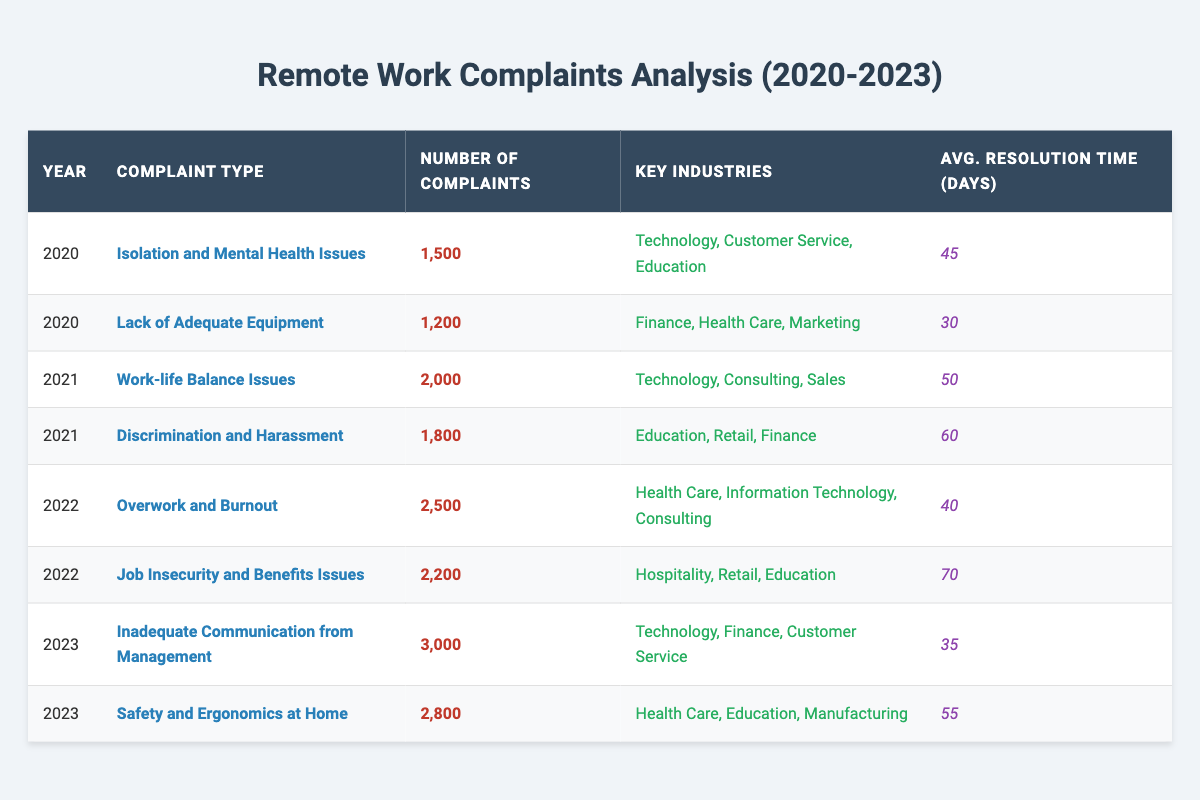What was the most common type of remote work complaint in 2023? In 2023, "Inadequate Communication from Management" had the highest number of complaints at 3,000.
Answer: Inadequate Communication from Management How many complaints were reported for "Job Insecurity and Benefits Issues" in 2022? The specific row for "Job Insecurity and Benefits Issues" in 2022 shows there were 2,200 complaints.
Answer: 2,200 Which year had the fewest total complaints? By adding up the complaints from each year: 2020 (2,700), 2021 (3,800), 2022 (4,700), and 2023 (5,800), the year 2020 had the fewest total complaints with 2,700.
Answer: 2020 What is the average resolution time for complaints related to "Overwork and Burnout" in 2022? The average resolution time for "Overwork and Burnout" listed in 2022 is 40 days.
Answer: 40 days True or False: "Isolation and Mental Health Issues" was the most complained about issue in 2021. In 2021, the complaints were highest for "Work-life Balance Issues" with 2,000 complaints compared to "Isolation and Mental Health Issues" which appears only in 2020.
Answer: False What are the key industries for "Safety and Ergonomics at Home" in 2023? The data for "Safety and Ergonomics at Home" shows that the key industries are Health Care, Education, and Manufacturing.
Answer: Health Care, Education, Manufacturing How many complaints were related to "Lack of Adequate Equipment" and "Isolation and Mental Health Issues" combined in 2020? Summing the complaints for both issue types: 1,200 (Lack of Adequate Equipment) + 1,500 (Isolation and Mental Health Issues) equals 2,700.
Answer: 2,700 Which year had the highest average resolution time for complaints? The year 2022 has the highest average resolution time with 70 days for "Job Insecurity and Benefits Issues."
Answer: 2022 What percentage of complaints in 2023 were related to "Safety and Ergonomics at Home"? The total complaints in 2023 are 3,000 (Inadequate Communication) + 2,800 (Safety and Ergonomics) = 5,800; then, (2,800 / 5,800) * 100 results in approximately 48.28%.
Answer: Approximately 48.28% Which complaint type has the least average resolution time and what is that time? Among the listed complaints, "Lack of Adequate Equipment" has the least average resolution time of 30 days.
Answer: 30 days 